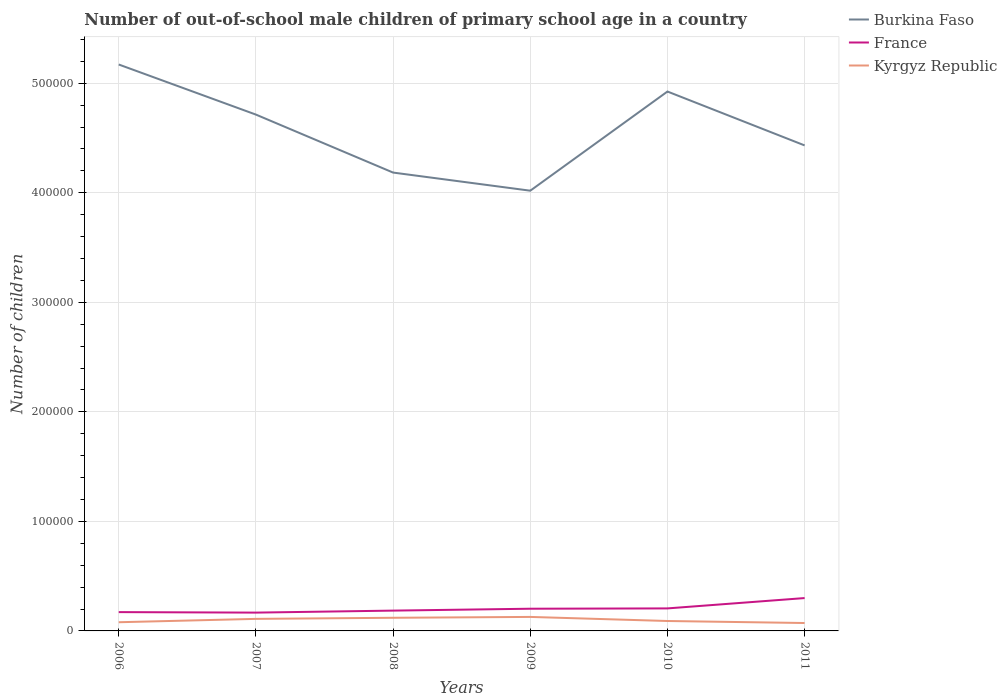Across all years, what is the maximum number of out-of-school male children in France?
Keep it short and to the point. 1.67e+04. What is the total number of out-of-school male children in Burkina Faso in the graph?
Your response must be concise. 4.57e+04. What is the difference between the highest and the second highest number of out-of-school male children in Burkina Faso?
Your answer should be very brief. 1.15e+05. Is the number of out-of-school male children in Burkina Faso strictly greater than the number of out-of-school male children in France over the years?
Ensure brevity in your answer.  No. How many lines are there?
Offer a very short reply. 3. How many years are there in the graph?
Your answer should be compact. 6. What is the difference between two consecutive major ticks on the Y-axis?
Provide a short and direct response. 1.00e+05. Are the values on the major ticks of Y-axis written in scientific E-notation?
Offer a terse response. No. Does the graph contain any zero values?
Offer a very short reply. No. Does the graph contain grids?
Provide a succinct answer. Yes. Where does the legend appear in the graph?
Your response must be concise. Top right. How many legend labels are there?
Provide a succinct answer. 3. How are the legend labels stacked?
Keep it short and to the point. Vertical. What is the title of the graph?
Give a very brief answer. Number of out-of-school male children of primary school age in a country. Does "High income: nonOECD" appear as one of the legend labels in the graph?
Give a very brief answer. No. What is the label or title of the X-axis?
Ensure brevity in your answer.  Years. What is the label or title of the Y-axis?
Ensure brevity in your answer.  Number of children. What is the Number of children in Burkina Faso in 2006?
Your answer should be compact. 5.17e+05. What is the Number of children in France in 2006?
Provide a short and direct response. 1.72e+04. What is the Number of children of Kyrgyz Republic in 2006?
Provide a succinct answer. 7932. What is the Number of children in Burkina Faso in 2007?
Provide a succinct answer. 4.71e+05. What is the Number of children in France in 2007?
Offer a very short reply. 1.67e+04. What is the Number of children in Kyrgyz Republic in 2007?
Ensure brevity in your answer.  1.10e+04. What is the Number of children in Burkina Faso in 2008?
Provide a succinct answer. 4.18e+05. What is the Number of children of France in 2008?
Keep it short and to the point. 1.85e+04. What is the Number of children of Kyrgyz Republic in 2008?
Give a very brief answer. 1.20e+04. What is the Number of children in Burkina Faso in 2009?
Ensure brevity in your answer.  4.02e+05. What is the Number of children of France in 2009?
Keep it short and to the point. 2.03e+04. What is the Number of children in Kyrgyz Republic in 2009?
Keep it short and to the point. 1.28e+04. What is the Number of children in Burkina Faso in 2010?
Your answer should be compact. 4.92e+05. What is the Number of children in France in 2010?
Your answer should be very brief. 2.06e+04. What is the Number of children in Kyrgyz Republic in 2010?
Your answer should be compact. 9061. What is the Number of children of Burkina Faso in 2011?
Offer a terse response. 4.43e+05. What is the Number of children in France in 2011?
Provide a succinct answer. 3.00e+04. What is the Number of children in Kyrgyz Republic in 2011?
Offer a very short reply. 7212. Across all years, what is the maximum Number of children in Burkina Faso?
Your answer should be compact. 5.17e+05. Across all years, what is the maximum Number of children of France?
Your response must be concise. 3.00e+04. Across all years, what is the maximum Number of children in Kyrgyz Republic?
Keep it short and to the point. 1.28e+04. Across all years, what is the minimum Number of children in Burkina Faso?
Provide a short and direct response. 4.02e+05. Across all years, what is the minimum Number of children of France?
Keep it short and to the point. 1.67e+04. Across all years, what is the minimum Number of children in Kyrgyz Republic?
Give a very brief answer. 7212. What is the total Number of children in Burkina Faso in the graph?
Your answer should be compact. 2.74e+06. What is the total Number of children of France in the graph?
Your answer should be compact. 1.23e+05. What is the total Number of children of Kyrgyz Republic in the graph?
Keep it short and to the point. 6.00e+04. What is the difference between the Number of children of Burkina Faso in 2006 and that in 2007?
Make the answer very short. 4.57e+04. What is the difference between the Number of children of France in 2006 and that in 2007?
Offer a terse response. 456. What is the difference between the Number of children in Kyrgyz Republic in 2006 and that in 2007?
Ensure brevity in your answer.  -3066. What is the difference between the Number of children of Burkina Faso in 2006 and that in 2008?
Offer a terse response. 9.87e+04. What is the difference between the Number of children of France in 2006 and that in 2008?
Provide a succinct answer. -1361. What is the difference between the Number of children in Kyrgyz Republic in 2006 and that in 2008?
Your answer should be very brief. -4057. What is the difference between the Number of children in Burkina Faso in 2006 and that in 2009?
Offer a very short reply. 1.15e+05. What is the difference between the Number of children of France in 2006 and that in 2009?
Your response must be concise. -3088. What is the difference between the Number of children of Kyrgyz Republic in 2006 and that in 2009?
Keep it short and to the point. -4848. What is the difference between the Number of children of Burkina Faso in 2006 and that in 2010?
Provide a succinct answer. 2.47e+04. What is the difference between the Number of children in France in 2006 and that in 2010?
Offer a very short reply. -3371. What is the difference between the Number of children of Kyrgyz Republic in 2006 and that in 2010?
Provide a short and direct response. -1129. What is the difference between the Number of children in Burkina Faso in 2006 and that in 2011?
Provide a short and direct response. 7.39e+04. What is the difference between the Number of children of France in 2006 and that in 2011?
Provide a succinct answer. -1.28e+04. What is the difference between the Number of children in Kyrgyz Republic in 2006 and that in 2011?
Keep it short and to the point. 720. What is the difference between the Number of children of Burkina Faso in 2007 and that in 2008?
Offer a very short reply. 5.29e+04. What is the difference between the Number of children in France in 2007 and that in 2008?
Provide a short and direct response. -1817. What is the difference between the Number of children of Kyrgyz Republic in 2007 and that in 2008?
Your response must be concise. -991. What is the difference between the Number of children of Burkina Faso in 2007 and that in 2009?
Your answer should be compact. 6.95e+04. What is the difference between the Number of children of France in 2007 and that in 2009?
Offer a very short reply. -3544. What is the difference between the Number of children in Kyrgyz Republic in 2007 and that in 2009?
Your answer should be compact. -1782. What is the difference between the Number of children of Burkina Faso in 2007 and that in 2010?
Give a very brief answer. -2.11e+04. What is the difference between the Number of children in France in 2007 and that in 2010?
Offer a terse response. -3827. What is the difference between the Number of children in Kyrgyz Republic in 2007 and that in 2010?
Provide a succinct answer. 1937. What is the difference between the Number of children of Burkina Faso in 2007 and that in 2011?
Your answer should be compact. 2.81e+04. What is the difference between the Number of children in France in 2007 and that in 2011?
Offer a terse response. -1.33e+04. What is the difference between the Number of children of Kyrgyz Republic in 2007 and that in 2011?
Keep it short and to the point. 3786. What is the difference between the Number of children of Burkina Faso in 2008 and that in 2009?
Give a very brief answer. 1.65e+04. What is the difference between the Number of children of France in 2008 and that in 2009?
Your answer should be very brief. -1727. What is the difference between the Number of children in Kyrgyz Republic in 2008 and that in 2009?
Give a very brief answer. -791. What is the difference between the Number of children in Burkina Faso in 2008 and that in 2010?
Provide a short and direct response. -7.40e+04. What is the difference between the Number of children of France in 2008 and that in 2010?
Provide a short and direct response. -2010. What is the difference between the Number of children in Kyrgyz Republic in 2008 and that in 2010?
Give a very brief answer. 2928. What is the difference between the Number of children of Burkina Faso in 2008 and that in 2011?
Your answer should be compact. -2.48e+04. What is the difference between the Number of children of France in 2008 and that in 2011?
Offer a very short reply. -1.15e+04. What is the difference between the Number of children in Kyrgyz Republic in 2008 and that in 2011?
Make the answer very short. 4777. What is the difference between the Number of children in Burkina Faso in 2009 and that in 2010?
Provide a short and direct response. -9.05e+04. What is the difference between the Number of children of France in 2009 and that in 2010?
Your response must be concise. -283. What is the difference between the Number of children in Kyrgyz Republic in 2009 and that in 2010?
Make the answer very short. 3719. What is the difference between the Number of children of Burkina Faso in 2009 and that in 2011?
Make the answer very short. -4.13e+04. What is the difference between the Number of children in France in 2009 and that in 2011?
Keep it short and to the point. -9732. What is the difference between the Number of children in Kyrgyz Republic in 2009 and that in 2011?
Provide a short and direct response. 5568. What is the difference between the Number of children of Burkina Faso in 2010 and that in 2011?
Give a very brief answer. 4.92e+04. What is the difference between the Number of children in France in 2010 and that in 2011?
Your response must be concise. -9449. What is the difference between the Number of children in Kyrgyz Republic in 2010 and that in 2011?
Your answer should be very brief. 1849. What is the difference between the Number of children of Burkina Faso in 2006 and the Number of children of France in 2007?
Your response must be concise. 5.00e+05. What is the difference between the Number of children in Burkina Faso in 2006 and the Number of children in Kyrgyz Republic in 2007?
Offer a very short reply. 5.06e+05. What is the difference between the Number of children in France in 2006 and the Number of children in Kyrgyz Republic in 2007?
Your answer should be very brief. 6181. What is the difference between the Number of children in Burkina Faso in 2006 and the Number of children in France in 2008?
Keep it short and to the point. 4.99e+05. What is the difference between the Number of children in Burkina Faso in 2006 and the Number of children in Kyrgyz Republic in 2008?
Make the answer very short. 5.05e+05. What is the difference between the Number of children of France in 2006 and the Number of children of Kyrgyz Republic in 2008?
Your answer should be very brief. 5190. What is the difference between the Number of children in Burkina Faso in 2006 and the Number of children in France in 2009?
Your answer should be very brief. 4.97e+05. What is the difference between the Number of children of Burkina Faso in 2006 and the Number of children of Kyrgyz Republic in 2009?
Keep it short and to the point. 5.04e+05. What is the difference between the Number of children of France in 2006 and the Number of children of Kyrgyz Republic in 2009?
Offer a terse response. 4399. What is the difference between the Number of children of Burkina Faso in 2006 and the Number of children of France in 2010?
Keep it short and to the point. 4.97e+05. What is the difference between the Number of children in Burkina Faso in 2006 and the Number of children in Kyrgyz Republic in 2010?
Make the answer very short. 5.08e+05. What is the difference between the Number of children in France in 2006 and the Number of children in Kyrgyz Republic in 2010?
Provide a short and direct response. 8118. What is the difference between the Number of children of Burkina Faso in 2006 and the Number of children of France in 2011?
Offer a very short reply. 4.87e+05. What is the difference between the Number of children of Burkina Faso in 2006 and the Number of children of Kyrgyz Republic in 2011?
Offer a terse response. 5.10e+05. What is the difference between the Number of children of France in 2006 and the Number of children of Kyrgyz Republic in 2011?
Make the answer very short. 9967. What is the difference between the Number of children in Burkina Faso in 2007 and the Number of children in France in 2008?
Keep it short and to the point. 4.53e+05. What is the difference between the Number of children in Burkina Faso in 2007 and the Number of children in Kyrgyz Republic in 2008?
Offer a terse response. 4.59e+05. What is the difference between the Number of children in France in 2007 and the Number of children in Kyrgyz Republic in 2008?
Ensure brevity in your answer.  4734. What is the difference between the Number of children of Burkina Faso in 2007 and the Number of children of France in 2009?
Give a very brief answer. 4.51e+05. What is the difference between the Number of children of Burkina Faso in 2007 and the Number of children of Kyrgyz Republic in 2009?
Provide a succinct answer. 4.59e+05. What is the difference between the Number of children in France in 2007 and the Number of children in Kyrgyz Republic in 2009?
Offer a very short reply. 3943. What is the difference between the Number of children of Burkina Faso in 2007 and the Number of children of France in 2010?
Give a very brief answer. 4.51e+05. What is the difference between the Number of children in Burkina Faso in 2007 and the Number of children in Kyrgyz Republic in 2010?
Provide a succinct answer. 4.62e+05. What is the difference between the Number of children in France in 2007 and the Number of children in Kyrgyz Republic in 2010?
Your answer should be very brief. 7662. What is the difference between the Number of children in Burkina Faso in 2007 and the Number of children in France in 2011?
Provide a succinct answer. 4.41e+05. What is the difference between the Number of children in Burkina Faso in 2007 and the Number of children in Kyrgyz Republic in 2011?
Provide a short and direct response. 4.64e+05. What is the difference between the Number of children in France in 2007 and the Number of children in Kyrgyz Republic in 2011?
Offer a very short reply. 9511. What is the difference between the Number of children in Burkina Faso in 2008 and the Number of children in France in 2009?
Offer a terse response. 3.98e+05. What is the difference between the Number of children in Burkina Faso in 2008 and the Number of children in Kyrgyz Republic in 2009?
Provide a succinct answer. 4.06e+05. What is the difference between the Number of children in France in 2008 and the Number of children in Kyrgyz Republic in 2009?
Give a very brief answer. 5760. What is the difference between the Number of children in Burkina Faso in 2008 and the Number of children in France in 2010?
Ensure brevity in your answer.  3.98e+05. What is the difference between the Number of children in Burkina Faso in 2008 and the Number of children in Kyrgyz Republic in 2010?
Your answer should be compact. 4.09e+05. What is the difference between the Number of children of France in 2008 and the Number of children of Kyrgyz Republic in 2010?
Your response must be concise. 9479. What is the difference between the Number of children of Burkina Faso in 2008 and the Number of children of France in 2011?
Your response must be concise. 3.88e+05. What is the difference between the Number of children of Burkina Faso in 2008 and the Number of children of Kyrgyz Republic in 2011?
Your answer should be compact. 4.11e+05. What is the difference between the Number of children of France in 2008 and the Number of children of Kyrgyz Republic in 2011?
Your answer should be very brief. 1.13e+04. What is the difference between the Number of children of Burkina Faso in 2009 and the Number of children of France in 2010?
Your response must be concise. 3.81e+05. What is the difference between the Number of children of Burkina Faso in 2009 and the Number of children of Kyrgyz Republic in 2010?
Offer a terse response. 3.93e+05. What is the difference between the Number of children of France in 2009 and the Number of children of Kyrgyz Republic in 2010?
Offer a terse response. 1.12e+04. What is the difference between the Number of children of Burkina Faso in 2009 and the Number of children of France in 2011?
Your answer should be very brief. 3.72e+05. What is the difference between the Number of children of Burkina Faso in 2009 and the Number of children of Kyrgyz Republic in 2011?
Make the answer very short. 3.95e+05. What is the difference between the Number of children in France in 2009 and the Number of children in Kyrgyz Republic in 2011?
Ensure brevity in your answer.  1.31e+04. What is the difference between the Number of children of Burkina Faso in 2010 and the Number of children of France in 2011?
Offer a terse response. 4.62e+05. What is the difference between the Number of children of Burkina Faso in 2010 and the Number of children of Kyrgyz Republic in 2011?
Provide a succinct answer. 4.85e+05. What is the difference between the Number of children in France in 2010 and the Number of children in Kyrgyz Republic in 2011?
Offer a very short reply. 1.33e+04. What is the average Number of children in Burkina Faso per year?
Give a very brief answer. 4.57e+05. What is the average Number of children of France per year?
Ensure brevity in your answer.  2.05e+04. What is the average Number of children in Kyrgyz Republic per year?
Provide a succinct answer. 9995.33. In the year 2006, what is the difference between the Number of children in Burkina Faso and Number of children in France?
Offer a terse response. 5.00e+05. In the year 2006, what is the difference between the Number of children in Burkina Faso and Number of children in Kyrgyz Republic?
Keep it short and to the point. 5.09e+05. In the year 2006, what is the difference between the Number of children of France and Number of children of Kyrgyz Republic?
Your response must be concise. 9247. In the year 2007, what is the difference between the Number of children of Burkina Faso and Number of children of France?
Offer a very short reply. 4.55e+05. In the year 2007, what is the difference between the Number of children of Burkina Faso and Number of children of Kyrgyz Republic?
Provide a short and direct response. 4.60e+05. In the year 2007, what is the difference between the Number of children in France and Number of children in Kyrgyz Republic?
Your response must be concise. 5725. In the year 2008, what is the difference between the Number of children of Burkina Faso and Number of children of France?
Provide a short and direct response. 4.00e+05. In the year 2008, what is the difference between the Number of children of Burkina Faso and Number of children of Kyrgyz Republic?
Provide a short and direct response. 4.06e+05. In the year 2008, what is the difference between the Number of children of France and Number of children of Kyrgyz Republic?
Your answer should be compact. 6551. In the year 2009, what is the difference between the Number of children of Burkina Faso and Number of children of France?
Provide a succinct answer. 3.82e+05. In the year 2009, what is the difference between the Number of children in Burkina Faso and Number of children in Kyrgyz Republic?
Give a very brief answer. 3.89e+05. In the year 2009, what is the difference between the Number of children of France and Number of children of Kyrgyz Republic?
Offer a very short reply. 7487. In the year 2010, what is the difference between the Number of children in Burkina Faso and Number of children in France?
Your answer should be very brief. 4.72e+05. In the year 2010, what is the difference between the Number of children in Burkina Faso and Number of children in Kyrgyz Republic?
Provide a short and direct response. 4.83e+05. In the year 2010, what is the difference between the Number of children in France and Number of children in Kyrgyz Republic?
Ensure brevity in your answer.  1.15e+04. In the year 2011, what is the difference between the Number of children in Burkina Faso and Number of children in France?
Your response must be concise. 4.13e+05. In the year 2011, what is the difference between the Number of children in Burkina Faso and Number of children in Kyrgyz Republic?
Ensure brevity in your answer.  4.36e+05. In the year 2011, what is the difference between the Number of children of France and Number of children of Kyrgyz Republic?
Provide a short and direct response. 2.28e+04. What is the ratio of the Number of children in Burkina Faso in 2006 to that in 2007?
Provide a succinct answer. 1.1. What is the ratio of the Number of children in France in 2006 to that in 2007?
Your answer should be very brief. 1.03. What is the ratio of the Number of children in Kyrgyz Republic in 2006 to that in 2007?
Offer a very short reply. 0.72. What is the ratio of the Number of children in Burkina Faso in 2006 to that in 2008?
Offer a terse response. 1.24. What is the ratio of the Number of children of France in 2006 to that in 2008?
Provide a short and direct response. 0.93. What is the ratio of the Number of children of Kyrgyz Republic in 2006 to that in 2008?
Your answer should be compact. 0.66. What is the ratio of the Number of children in Burkina Faso in 2006 to that in 2009?
Provide a short and direct response. 1.29. What is the ratio of the Number of children of France in 2006 to that in 2009?
Make the answer very short. 0.85. What is the ratio of the Number of children of Kyrgyz Republic in 2006 to that in 2009?
Provide a short and direct response. 0.62. What is the ratio of the Number of children of Burkina Faso in 2006 to that in 2010?
Provide a succinct answer. 1.05. What is the ratio of the Number of children in France in 2006 to that in 2010?
Your answer should be compact. 0.84. What is the ratio of the Number of children in Kyrgyz Republic in 2006 to that in 2010?
Make the answer very short. 0.88. What is the ratio of the Number of children of France in 2006 to that in 2011?
Offer a very short reply. 0.57. What is the ratio of the Number of children in Kyrgyz Republic in 2006 to that in 2011?
Your response must be concise. 1.1. What is the ratio of the Number of children of Burkina Faso in 2007 to that in 2008?
Offer a very short reply. 1.13. What is the ratio of the Number of children of France in 2007 to that in 2008?
Offer a terse response. 0.9. What is the ratio of the Number of children of Kyrgyz Republic in 2007 to that in 2008?
Offer a very short reply. 0.92. What is the ratio of the Number of children in Burkina Faso in 2007 to that in 2009?
Offer a very short reply. 1.17. What is the ratio of the Number of children in France in 2007 to that in 2009?
Give a very brief answer. 0.83. What is the ratio of the Number of children in Kyrgyz Republic in 2007 to that in 2009?
Give a very brief answer. 0.86. What is the ratio of the Number of children of Burkina Faso in 2007 to that in 2010?
Your answer should be compact. 0.96. What is the ratio of the Number of children of France in 2007 to that in 2010?
Your answer should be very brief. 0.81. What is the ratio of the Number of children of Kyrgyz Republic in 2007 to that in 2010?
Provide a succinct answer. 1.21. What is the ratio of the Number of children of Burkina Faso in 2007 to that in 2011?
Offer a very short reply. 1.06. What is the ratio of the Number of children of France in 2007 to that in 2011?
Make the answer very short. 0.56. What is the ratio of the Number of children in Kyrgyz Republic in 2007 to that in 2011?
Keep it short and to the point. 1.52. What is the ratio of the Number of children of Burkina Faso in 2008 to that in 2009?
Provide a succinct answer. 1.04. What is the ratio of the Number of children of France in 2008 to that in 2009?
Make the answer very short. 0.91. What is the ratio of the Number of children in Kyrgyz Republic in 2008 to that in 2009?
Provide a succinct answer. 0.94. What is the ratio of the Number of children in Burkina Faso in 2008 to that in 2010?
Your answer should be compact. 0.85. What is the ratio of the Number of children of France in 2008 to that in 2010?
Your answer should be compact. 0.9. What is the ratio of the Number of children in Kyrgyz Republic in 2008 to that in 2010?
Offer a terse response. 1.32. What is the ratio of the Number of children of Burkina Faso in 2008 to that in 2011?
Your response must be concise. 0.94. What is the ratio of the Number of children of France in 2008 to that in 2011?
Offer a very short reply. 0.62. What is the ratio of the Number of children in Kyrgyz Republic in 2008 to that in 2011?
Your answer should be compact. 1.66. What is the ratio of the Number of children in Burkina Faso in 2009 to that in 2010?
Ensure brevity in your answer.  0.82. What is the ratio of the Number of children in France in 2009 to that in 2010?
Your answer should be compact. 0.99. What is the ratio of the Number of children in Kyrgyz Republic in 2009 to that in 2010?
Offer a terse response. 1.41. What is the ratio of the Number of children in Burkina Faso in 2009 to that in 2011?
Offer a terse response. 0.91. What is the ratio of the Number of children of France in 2009 to that in 2011?
Your response must be concise. 0.68. What is the ratio of the Number of children of Kyrgyz Republic in 2009 to that in 2011?
Your answer should be compact. 1.77. What is the ratio of the Number of children in Burkina Faso in 2010 to that in 2011?
Provide a short and direct response. 1.11. What is the ratio of the Number of children in France in 2010 to that in 2011?
Your answer should be very brief. 0.69. What is the ratio of the Number of children in Kyrgyz Republic in 2010 to that in 2011?
Your response must be concise. 1.26. What is the difference between the highest and the second highest Number of children of Burkina Faso?
Provide a succinct answer. 2.47e+04. What is the difference between the highest and the second highest Number of children in France?
Give a very brief answer. 9449. What is the difference between the highest and the second highest Number of children of Kyrgyz Republic?
Ensure brevity in your answer.  791. What is the difference between the highest and the lowest Number of children in Burkina Faso?
Offer a very short reply. 1.15e+05. What is the difference between the highest and the lowest Number of children in France?
Your answer should be compact. 1.33e+04. What is the difference between the highest and the lowest Number of children of Kyrgyz Republic?
Provide a succinct answer. 5568. 